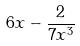Convert formula to latex. <formula><loc_0><loc_0><loc_500><loc_500>6 x - \frac { 2 } { 7 x ^ { 3 } }</formula> 